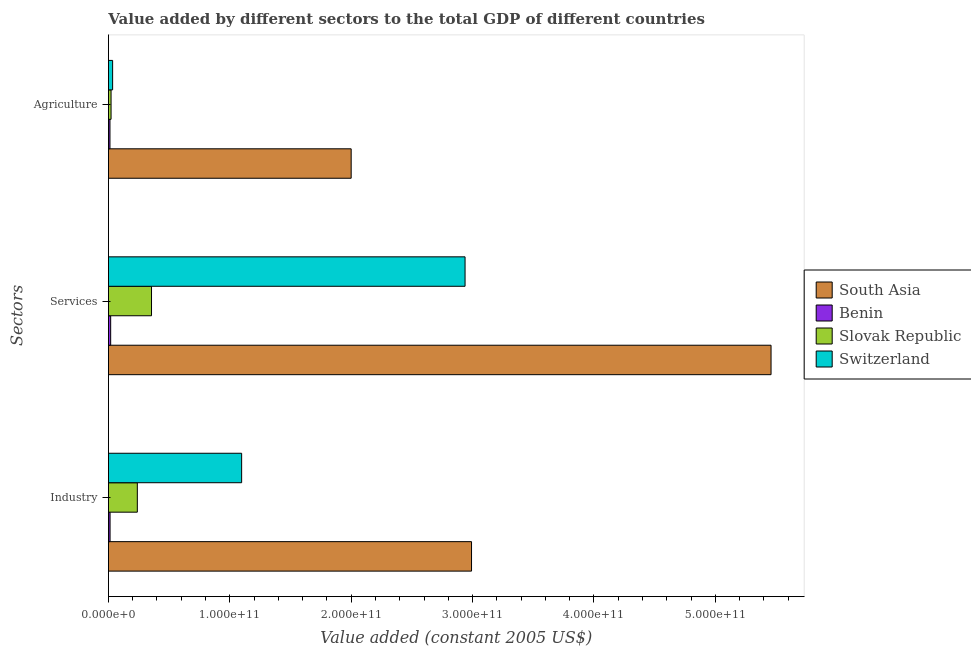Are the number of bars per tick equal to the number of legend labels?
Offer a terse response. Yes. How many bars are there on the 1st tick from the top?
Provide a succinct answer. 4. What is the label of the 2nd group of bars from the top?
Offer a terse response. Services. What is the value added by industrial sector in Benin?
Your answer should be compact. 1.35e+09. Across all countries, what is the maximum value added by agricultural sector?
Provide a short and direct response. 2.00e+11. Across all countries, what is the minimum value added by agricultural sector?
Keep it short and to the point. 1.26e+09. In which country was the value added by industrial sector minimum?
Your answer should be very brief. Benin. What is the total value added by industrial sector in the graph?
Ensure brevity in your answer.  4.34e+11. What is the difference between the value added by services in Slovak Republic and that in South Asia?
Give a very brief answer. -5.10e+11. What is the difference between the value added by industrial sector in Slovak Republic and the value added by services in South Asia?
Your answer should be very brief. -5.22e+11. What is the average value added by services per country?
Keep it short and to the point. 2.19e+11. What is the difference between the value added by services and value added by agricultural sector in Benin?
Make the answer very short. 5.83e+08. What is the ratio of the value added by industrial sector in Benin to that in Slovak Republic?
Your answer should be compact. 0.06. Is the value added by industrial sector in Benin less than that in Switzerland?
Ensure brevity in your answer.  Yes. Is the difference between the value added by agricultural sector in South Asia and Slovak Republic greater than the difference between the value added by industrial sector in South Asia and Slovak Republic?
Make the answer very short. No. What is the difference between the highest and the second highest value added by industrial sector?
Provide a short and direct response. 1.89e+11. What is the difference between the highest and the lowest value added by industrial sector?
Provide a short and direct response. 2.98e+11. Is the sum of the value added by industrial sector in Slovak Republic and South Asia greater than the maximum value added by agricultural sector across all countries?
Your response must be concise. Yes. What does the 2nd bar from the top in Services represents?
Provide a succinct answer. Slovak Republic. What does the 4th bar from the bottom in Services represents?
Provide a succinct answer. Switzerland. How many bars are there?
Your answer should be compact. 12. Are all the bars in the graph horizontal?
Offer a terse response. Yes. How many countries are there in the graph?
Give a very brief answer. 4. What is the difference between two consecutive major ticks on the X-axis?
Offer a very short reply. 1.00e+11. Where does the legend appear in the graph?
Your answer should be compact. Center right. What is the title of the graph?
Keep it short and to the point. Value added by different sectors to the total GDP of different countries. What is the label or title of the X-axis?
Your answer should be compact. Value added (constant 2005 US$). What is the label or title of the Y-axis?
Offer a very short reply. Sectors. What is the Value added (constant 2005 US$) of South Asia in Industry?
Make the answer very short. 2.99e+11. What is the Value added (constant 2005 US$) in Benin in Industry?
Provide a short and direct response. 1.35e+09. What is the Value added (constant 2005 US$) in Slovak Republic in Industry?
Your response must be concise. 2.38e+1. What is the Value added (constant 2005 US$) of Switzerland in Industry?
Your response must be concise. 1.10e+11. What is the Value added (constant 2005 US$) of South Asia in Services?
Provide a short and direct response. 5.46e+11. What is the Value added (constant 2005 US$) in Benin in Services?
Your answer should be very brief. 1.85e+09. What is the Value added (constant 2005 US$) of Slovak Republic in Services?
Ensure brevity in your answer.  3.55e+1. What is the Value added (constant 2005 US$) in Switzerland in Services?
Make the answer very short. 2.94e+11. What is the Value added (constant 2005 US$) in South Asia in Agriculture?
Your answer should be very brief. 2.00e+11. What is the Value added (constant 2005 US$) in Benin in Agriculture?
Your answer should be very brief. 1.26e+09. What is the Value added (constant 2005 US$) of Slovak Republic in Agriculture?
Ensure brevity in your answer.  2.17e+09. What is the Value added (constant 2005 US$) of Switzerland in Agriculture?
Provide a short and direct response. 3.46e+09. Across all Sectors, what is the maximum Value added (constant 2005 US$) in South Asia?
Your answer should be very brief. 5.46e+11. Across all Sectors, what is the maximum Value added (constant 2005 US$) in Benin?
Your answer should be compact. 1.85e+09. Across all Sectors, what is the maximum Value added (constant 2005 US$) in Slovak Republic?
Keep it short and to the point. 3.55e+1. Across all Sectors, what is the maximum Value added (constant 2005 US$) in Switzerland?
Offer a very short reply. 2.94e+11. Across all Sectors, what is the minimum Value added (constant 2005 US$) in South Asia?
Your answer should be very brief. 2.00e+11. Across all Sectors, what is the minimum Value added (constant 2005 US$) of Benin?
Your answer should be compact. 1.26e+09. Across all Sectors, what is the minimum Value added (constant 2005 US$) in Slovak Republic?
Provide a short and direct response. 2.17e+09. Across all Sectors, what is the minimum Value added (constant 2005 US$) in Switzerland?
Offer a terse response. 3.46e+09. What is the total Value added (constant 2005 US$) of South Asia in the graph?
Offer a very short reply. 1.04e+12. What is the total Value added (constant 2005 US$) in Benin in the graph?
Provide a succinct answer. 4.46e+09. What is the total Value added (constant 2005 US$) in Slovak Republic in the graph?
Keep it short and to the point. 6.15e+1. What is the total Value added (constant 2005 US$) of Switzerland in the graph?
Keep it short and to the point. 4.07e+11. What is the difference between the Value added (constant 2005 US$) of South Asia in Industry and that in Services?
Offer a terse response. -2.47e+11. What is the difference between the Value added (constant 2005 US$) in Benin in Industry and that in Services?
Your answer should be very brief. -4.99e+08. What is the difference between the Value added (constant 2005 US$) in Slovak Republic in Industry and that in Services?
Provide a short and direct response. -1.17e+1. What is the difference between the Value added (constant 2005 US$) of Switzerland in Industry and that in Services?
Offer a terse response. -1.84e+11. What is the difference between the Value added (constant 2005 US$) in South Asia in Industry and that in Agriculture?
Provide a short and direct response. 9.92e+1. What is the difference between the Value added (constant 2005 US$) in Benin in Industry and that in Agriculture?
Your answer should be very brief. 8.43e+07. What is the difference between the Value added (constant 2005 US$) of Slovak Republic in Industry and that in Agriculture?
Keep it short and to the point. 2.16e+1. What is the difference between the Value added (constant 2005 US$) of Switzerland in Industry and that in Agriculture?
Provide a short and direct response. 1.06e+11. What is the difference between the Value added (constant 2005 US$) of South Asia in Services and that in Agriculture?
Make the answer very short. 3.46e+11. What is the difference between the Value added (constant 2005 US$) of Benin in Services and that in Agriculture?
Make the answer very short. 5.83e+08. What is the difference between the Value added (constant 2005 US$) of Slovak Republic in Services and that in Agriculture?
Your response must be concise. 3.33e+1. What is the difference between the Value added (constant 2005 US$) of Switzerland in Services and that in Agriculture?
Provide a succinct answer. 2.90e+11. What is the difference between the Value added (constant 2005 US$) in South Asia in Industry and the Value added (constant 2005 US$) in Benin in Services?
Provide a succinct answer. 2.97e+11. What is the difference between the Value added (constant 2005 US$) in South Asia in Industry and the Value added (constant 2005 US$) in Slovak Republic in Services?
Make the answer very short. 2.64e+11. What is the difference between the Value added (constant 2005 US$) in South Asia in Industry and the Value added (constant 2005 US$) in Switzerland in Services?
Make the answer very short. 5.33e+09. What is the difference between the Value added (constant 2005 US$) in Benin in Industry and the Value added (constant 2005 US$) in Slovak Republic in Services?
Ensure brevity in your answer.  -3.41e+1. What is the difference between the Value added (constant 2005 US$) in Benin in Industry and the Value added (constant 2005 US$) in Switzerland in Services?
Your response must be concise. -2.92e+11. What is the difference between the Value added (constant 2005 US$) of Slovak Republic in Industry and the Value added (constant 2005 US$) of Switzerland in Services?
Make the answer very short. -2.70e+11. What is the difference between the Value added (constant 2005 US$) of South Asia in Industry and the Value added (constant 2005 US$) of Benin in Agriculture?
Your answer should be very brief. 2.98e+11. What is the difference between the Value added (constant 2005 US$) in South Asia in Industry and the Value added (constant 2005 US$) in Slovak Republic in Agriculture?
Ensure brevity in your answer.  2.97e+11. What is the difference between the Value added (constant 2005 US$) in South Asia in Industry and the Value added (constant 2005 US$) in Switzerland in Agriculture?
Provide a short and direct response. 2.96e+11. What is the difference between the Value added (constant 2005 US$) in Benin in Industry and the Value added (constant 2005 US$) in Slovak Republic in Agriculture?
Give a very brief answer. -8.23e+08. What is the difference between the Value added (constant 2005 US$) in Benin in Industry and the Value added (constant 2005 US$) in Switzerland in Agriculture?
Ensure brevity in your answer.  -2.11e+09. What is the difference between the Value added (constant 2005 US$) of Slovak Republic in Industry and the Value added (constant 2005 US$) of Switzerland in Agriculture?
Your answer should be compact. 2.03e+1. What is the difference between the Value added (constant 2005 US$) in South Asia in Services and the Value added (constant 2005 US$) in Benin in Agriculture?
Your response must be concise. 5.45e+11. What is the difference between the Value added (constant 2005 US$) of South Asia in Services and the Value added (constant 2005 US$) of Slovak Republic in Agriculture?
Ensure brevity in your answer.  5.44e+11. What is the difference between the Value added (constant 2005 US$) of South Asia in Services and the Value added (constant 2005 US$) of Switzerland in Agriculture?
Keep it short and to the point. 5.42e+11. What is the difference between the Value added (constant 2005 US$) of Benin in Services and the Value added (constant 2005 US$) of Slovak Republic in Agriculture?
Your response must be concise. -3.24e+08. What is the difference between the Value added (constant 2005 US$) of Benin in Services and the Value added (constant 2005 US$) of Switzerland in Agriculture?
Offer a terse response. -1.61e+09. What is the difference between the Value added (constant 2005 US$) in Slovak Republic in Services and the Value added (constant 2005 US$) in Switzerland in Agriculture?
Make the answer very short. 3.20e+1. What is the average Value added (constant 2005 US$) in South Asia per Sectors?
Provide a short and direct response. 3.48e+11. What is the average Value added (constant 2005 US$) of Benin per Sectors?
Provide a short and direct response. 1.49e+09. What is the average Value added (constant 2005 US$) in Slovak Republic per Sectors?
Give a very brief answer. 2.05e+1. What is the average Value added (constant 2005 US$) in Switzerland per Sectors?
Provide a succinct answer. 1.36e+11. What is the difference between the Value added (constant 2005 US$) in South Asia and Value added (constant 2005 US$) in Benin in Industry?
Your answer should be compact. 2.98e+11. What is the difference between the Value added (constant 2005 US$) of South Asia and Value added (constant 2005 US$) of Slovak Republic in Industry?
Give a very brief answer. 2.75e+11. What is the difference between the Value added (constant 2005 US$) in South Asia and Value added (constant 2005 US$) in Switzerland in Industry?
Your answer should be very brief. 1.89e+11. What is the difference between the Value added (constant 2005 US$) in Benin and Value added (constant 2005 US$) in Slovak Republic in Industry?
Your answer should be compact. -2.25e+1. What is the difference between the Value added (constant 2005 US$) in Benin and Value added (constant 2005 US$) in Switzerland in Industry?
Your response must be concise. -1.08e+11. What is the difference between the Value added (constant 2005 US$) in Slovak Republic and Value added (constant 2005 US$) in Switzerland in Industry?
Your answer should be very brief. -8.59e+1. What is the difference between the Value added (constant 2005 US$) of South Asia and Value added (constant 2005 US$) of Benin in Services?
Your response must be concise. 5.44e+11. What is the difference between the Value added (constant 2005 US$) in South Asia and Value added (constant 2005 US$) in Slovak Republic in Services?
Your answer should be very brief. 5.10e+11. What is the difference between the Value added (constant 2005 US$) of South Asia and Value added (constant 2005 US$) of Switzerland in Services?
Your answer should be compact. 2.52e+11. What is the difference between the Value added (constant 2005 US$) of Benin and Value added (constant 2005 US$) of Slovak Republic in Services?
Your answer should be very brief. -3.36e+1. What is the difference between the Value added (constant 2005 US$) in Benin and Value added (constant 2005 US$) in Switzerland in Services?
Offer a terse response. -2.92e+11. What is the difference between the Value added (constant 2005 US$) in Slovak Republic and Value added (constant 2005 US$) in Switzerland in Services?
Ensure brevity in your answer.  -2.58e+11. What is the difference between the Value added (constant 2005 US$) in South Asia and Value added (constant 2005 US$) in Benin in Agriculture?
Provide a short and direct response. 1.99e+11. What is the difference between the Value added (constant 2005 US$) in South Asia and Value added (constant 2005 US$) in Slovak Republic in Agriculture?
Offer a terse response. 1.98e+11. What is the difference between the Value added (constant 2005 US$) of South Asia and Value added (constant 2005 US$) of Switzerland in Agriculture?
Make the answer very short. 1.97e+11. What is the difference between the Value added (constant 2005 US$) in Benin and Value added (constant 2005 US$) in Slovak Republic in Agriculture?
Give a very brief answer. -9.07e+08. What is the difference between the Value added (constant 2005 US$) of Benin and Value added (constant 2005 US$) of Switzerland in Agriculture?
Offer a very short reply. -2.20e+09. What is the difference between the Value added (constant 2005 US$) of Slovak Republic and Value added (constant 2005 US$) of Switzerland in Agriculture?
Provide a succinct answer. -1.29e+09. What is the ratio of the Value added (constant 2005 US$) in South Asia in Industry to that in Services?
Keep it short and to the point. 0.55. What is the ratio of the Value added (constant 2005 US$) of Benin in Industry to that in Services?
Provide a short and direct response. 0.73. What is the ratio of the Value added (constant 2005 US$) of Slovak Republic in Industry to that in Services?
Provide a short and direct response. 0.67. What is the ratio of the Value added (constant 2005 US$) of Switzerland in Industry to that in Services?
Your answer should be compact. 0.37. What is the ratio of the Value added (constant 2005 US$) in South Asia in Industry to that in Agriculture?
Provide a succinct answer. 1.5. What is the ratio of the Value added (constant 2005 US$) in Benin in Industry to that in Agriculture?
Ensure brevity in your answer.  1.07. What is the ratio of the Value added (constant 2005 US$) in Slovak Republic in Industry to that in Agriculture?
Keep it short and to the point. 10.97. What is the ratio of the Value added (constant 2005 US$) in Switzerland in Industry to that in Agriculture?
Provide a short and direct response. 31.73. What is the ratio of the Value added (constant 2005 US$) of South Asia in Services to that in Agriculture?
Make the answer very short. 2.73. What is the ratio of the Value added (constant 2005 US$) in Benin in Services to that in Agriculture?
Provide a succinct answer. 1.46. What is the ratio of the Value added (constant 2005 US$) in Slovak Republic in Services to that in Agriculture?
Your answer should be compact. 16.35. What is the ratio of the Value added (constant 2005 US$) of Switzerland in Services to that in Agriculture?
Your answer should be compact. 84.94. What is the difference between the highest and the second highest Value added (constant 2005 US$) of South Asia?
Offer a very short reply. 2.47e+11. What is the difference between the highest and the second highest Value added (constant 2005 US$) of Benin?
Provide a short and direct response. 4.99e+08. What is the difference between the highest and the second highest Value added (constant 2005 US$) in Slovak Republic?
Keep it short and to the point. 1.17e+1. What is the difference between the highest and the second highest Value added (constant 2005 US$) of Switzerland?
Give a very brief answer. 1.84e+11. What is the difference between the highest and the lowest Value added (constant 2005 US$) of South Asia?
Your answer should be compact. 3.46e+11. What is the difference between the highest and the lowest Value added (constant 2005 US$) of Benin?
Your answer should be very brief. 5.83e+08. What is the difference between the highest and the lowest Value added (constant 2005 US$) in Slovak Republic?
Offer a very short reply. 3.33e+1. What is the difference between the highest and the lowest Value added (constant 2005 US$) of Switzerland?
Your answer should be compact. 2.90e+11. 